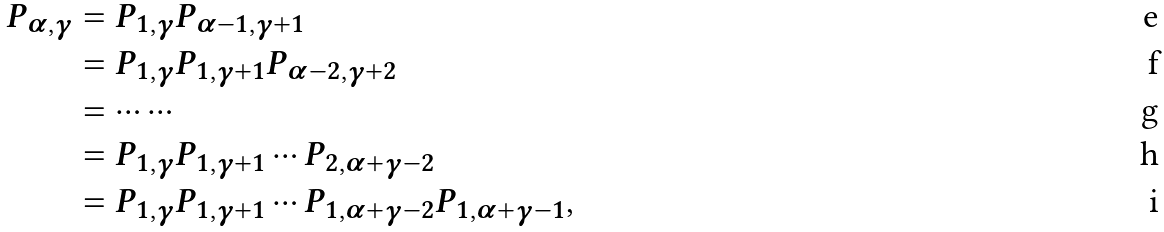Convert formula to latex. <formula><loc_0><loc_0><loc_500><loc_500>P _ { \alpha , \gamma } & = P _ { 1 , \gamma } P _ { \alpha - 1 , \gamma + 1 } \\ & = P _ { 1 , \gamma } P _ { 1 , \gamma + 1 } P _ { \alpha - 2 , \gamma + 2 } \\ & = \cdots \cdots \\ & = P _ { 1 , \gamma } P _ { 1 , \gamma + 1 } \cdots P _ { 2 , \alpha + \gamma - 2 } \\ & = P _ { 1 , \gamma } P _ { 1 , \gamma + 1 } \cdots P _ { 1 , \alpha + \gamma - 2 } P _ { 1 , \alpha + \gamma - 1 } ,</formula> 